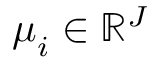<formula> <loc_0><loc_0><loc_500><loc_500>\mu _ { i } \in \mathbb { R } ^ { J }</formula> 